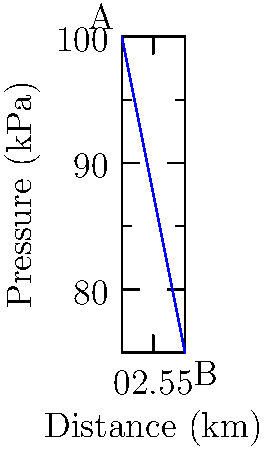In a water distribution network, the pressure drops linearly from point A to point B over a distance of 5 km, as shown in the graph. Given that the flow rate at point A is 0.5 m³/s and the pipe diameter is constant at 0.6 m, calculate the head loss per kilometer. Assume a kinematic viscosity of $1.0 \times 10^{-6}$ m²/s for water at 20°C. To solve this problem, we'll follow these steps:

1) First, calculate the velocity in the pipe:
   Area of pipe = $\pi r^2 = \pi (0.3\text{ m})^2 = 0.2827\text{ m}^2$
   Velocity = Flow rate / Area = $0.5\text{ m}^3/\text{s} / 0.2827\text{ m}^2 = 1.768\text{ m/s}$

2) Calculate the Reynolds number:
   $Re = \frac{vD}{\nu} = \frac{1.768\text{ m/s} \times 0.6\text{ m}}{1.0 \times 10^{-6}\text{ m}^2/\text{s}} = 1,060,800$

3) As Re > 4000, the flow is turbulent. Use the Swamee-Jain equation to find the friction factor:
   $f = \frac{0.25}{[\log_{10}(\frac{\epsilon}{3.7D} + \frac{5.74}{Re^{0.9}})]^2}$
   Assuming a smooth pipe ($\epsilon \approx 0$):
   $f = \frac{0.25}{[\log_{10}(\frac{5.74}{1060800^{0.9}})]^2} = 0.0182$

4) Use the Darcy-Weisbach equation to find the head loss:
   $h_f = f \times \frac{L}{D} \times \frac{v^2}{2g}$

5) From the graph, total pressure drop = 100 kPa - 75 kPa = 25 kPa
   Convert pressure to head: $h = \frac{P}{\rho g} = \frac{25000\text{ Pa}}{1000\text{ kg/m}^3 \times 9.81\text{ m/s}^2} = 2.55\text{ m}$

6) Equate this to the Darcy-Weisbach equation:
   $2.55\text{ m} = 0.0182 \times \frac{5000\text{ m}}{0.6\text{ m}} \times \frac{(1.768\text{ m/s})^2}{2 \times 9.81\text{ m/s}^2}$

7) Solve for head loss per kilometer:
   Head loss per km = $2.55\text{ m} / 5\text{ km} = 0.51\text{ m/km}$
Answer: 0.51 m/km 